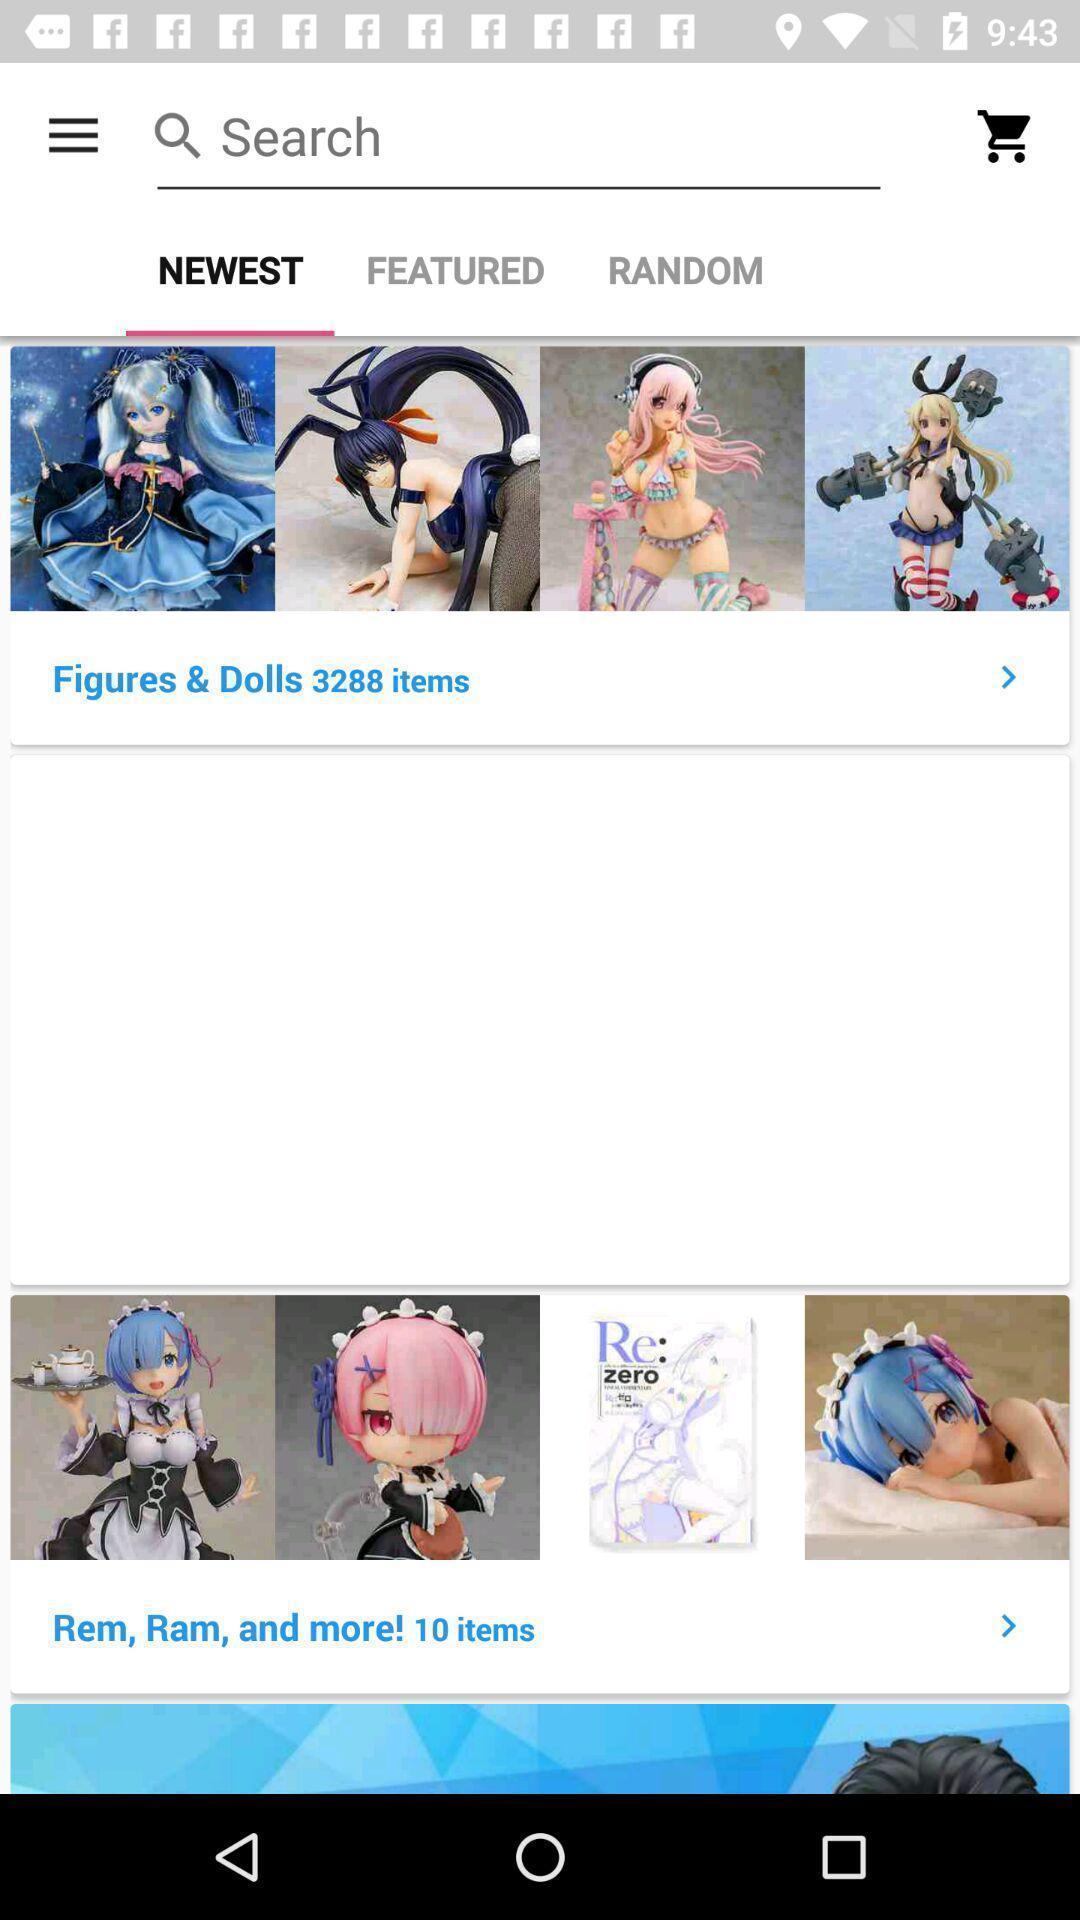Tell me about the visual elements in this screen capture. Window displaying a shopping app. 